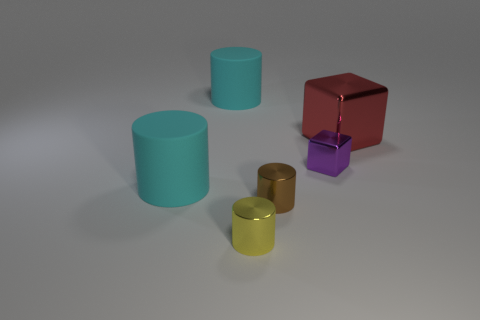Subtract all brown metal cylinders. How many cylinders are left? 3 Subtract all cylinders. How many objects are left? 2 Subtract all brown cylinders. How many cylinders are left? 3 Add 3 small cyan rubber blocks. How many objects exist? 9 Subtract 1 cylinders. How many cylinders are left? 3 Subtract all brown blocks. How many cyan cylinders are left? 2 Add 2 cyan rubber things. How many cyan rubber things exist? 4 Subtract 0 blue cylinders. How many objects are left? 6 Subtract all green cylinders. Subtract all brown balls. How many cylinders are left? 4 Subtract all metal blocks. Subtract all purple matte spheres. How many objects are left? 4 